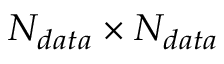Convert formula to latex. <formula><loc_0><loc_0><loc_500><loc_500>N _ { d a t a } \times N _ { d a t a }</formula> 